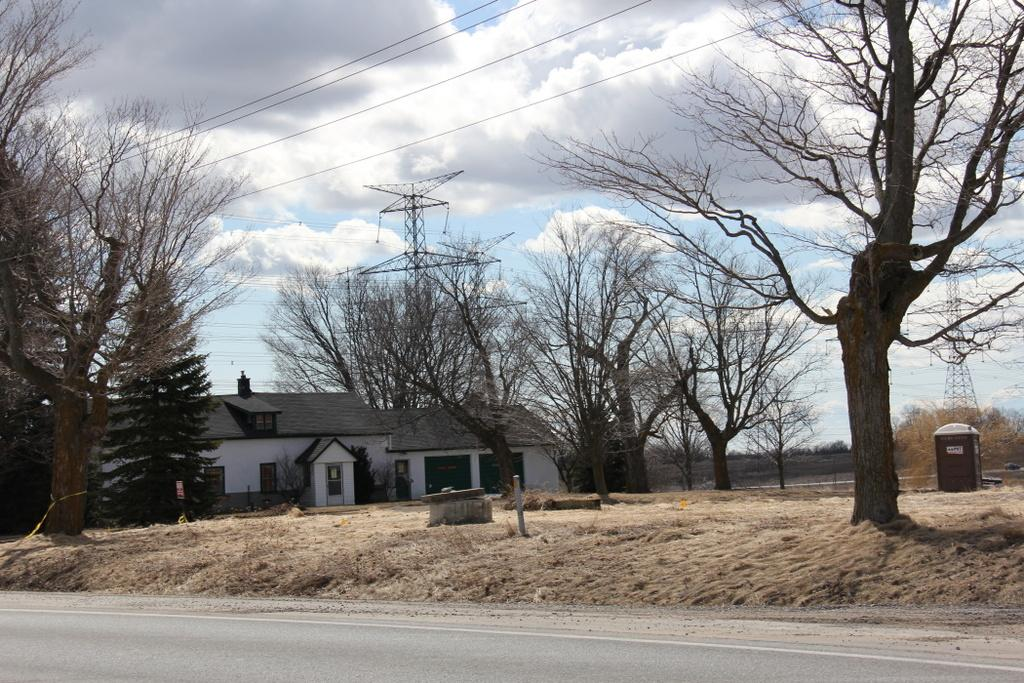What type of structure is present in the image? There is a building in the image. What colors are used for the building? The building is in white and gray color. What can be seen in the background of the image? There are dried trees and electric poles in the background of the image. What is visible in the sky in the image? The sky is visible in the image, and it is a combination of white and blue color. How many cherries are hanging from the electric poles in the image? There are no cherries present in the image; it features a building, dried trees, and electric poles. Can you describe the stretch of the building in the image? The image does not provide information about the building's stretch or dimensions. 